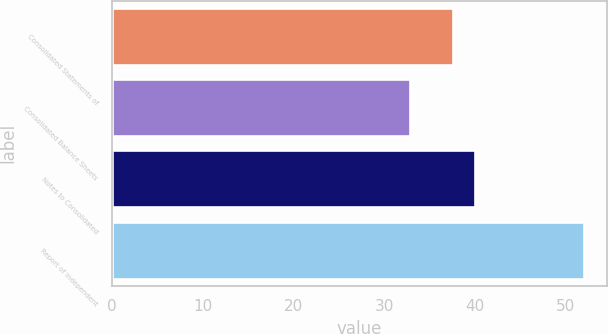Convert chart. <chart><loc_0><loc_0><loc_500><loc_500><bar_chart><fcel>Consolidated Statements of<fcel>Consolidated Balance Sheets<fcel>Notes to Consolidated<fcel>Report of Independent<nl><fcel>37.6<fcel>32.8<fcel>40<fcel>52<nl></chart> 